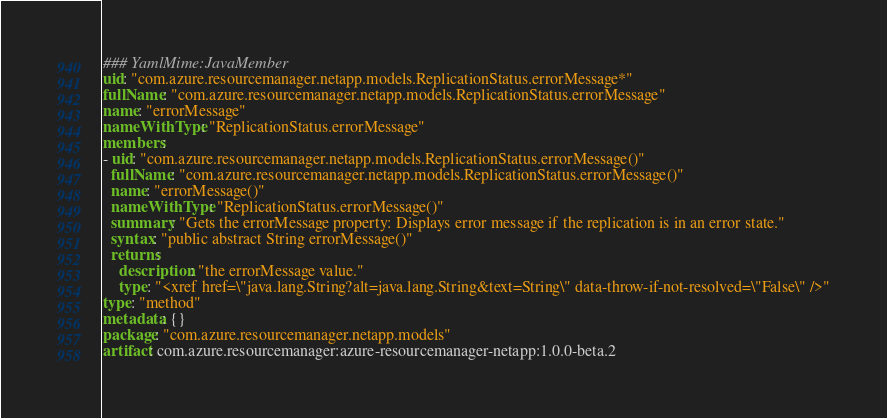Convert code to text. <code><loc_0><loc_0><loc_500><loc_500><_YAML_>### YamlMime:JavaMember
uid: "com.azure.resourcemanager.netapp.models.ReplicationStatus.errorMessage*"
fullName: "com.azure.resourcemanager.netapp.models.ReplicationStatus.errorMessage"
name: "errorMessage"
nameWithType: "ReplicationStatus.errorMessage"
members:
- uid: "com.azure.resourcemanager.netapp.models.ReplicationStatus.errorMessage()"
  fullName: "com.azure.resourcemanager.netapp.models.ReplicationStatus.errorMessage()"
  name: "errorMessage()"
  nameWithType: "ReplicationStatus.errorMessage()"
  summary: "Gets the errorMessage property: Displays error message if the replication is in an error state."
  syntax: "public abstract String errorMessage()"
  returns:
    description: "the errorMessage value."
    type: "<xref href=\"java.lang.String?alt=java.lang.String&text=String\" data-throw-if-not-resolved=\"False\" />"
type: "method"
metadata: {}
package: "com.azure.resourcemanager.netapp.models"
artifact: com.azure.resourcemanager:azure-resourcemanager-netapp:1.0.0-beta.2
</code> 